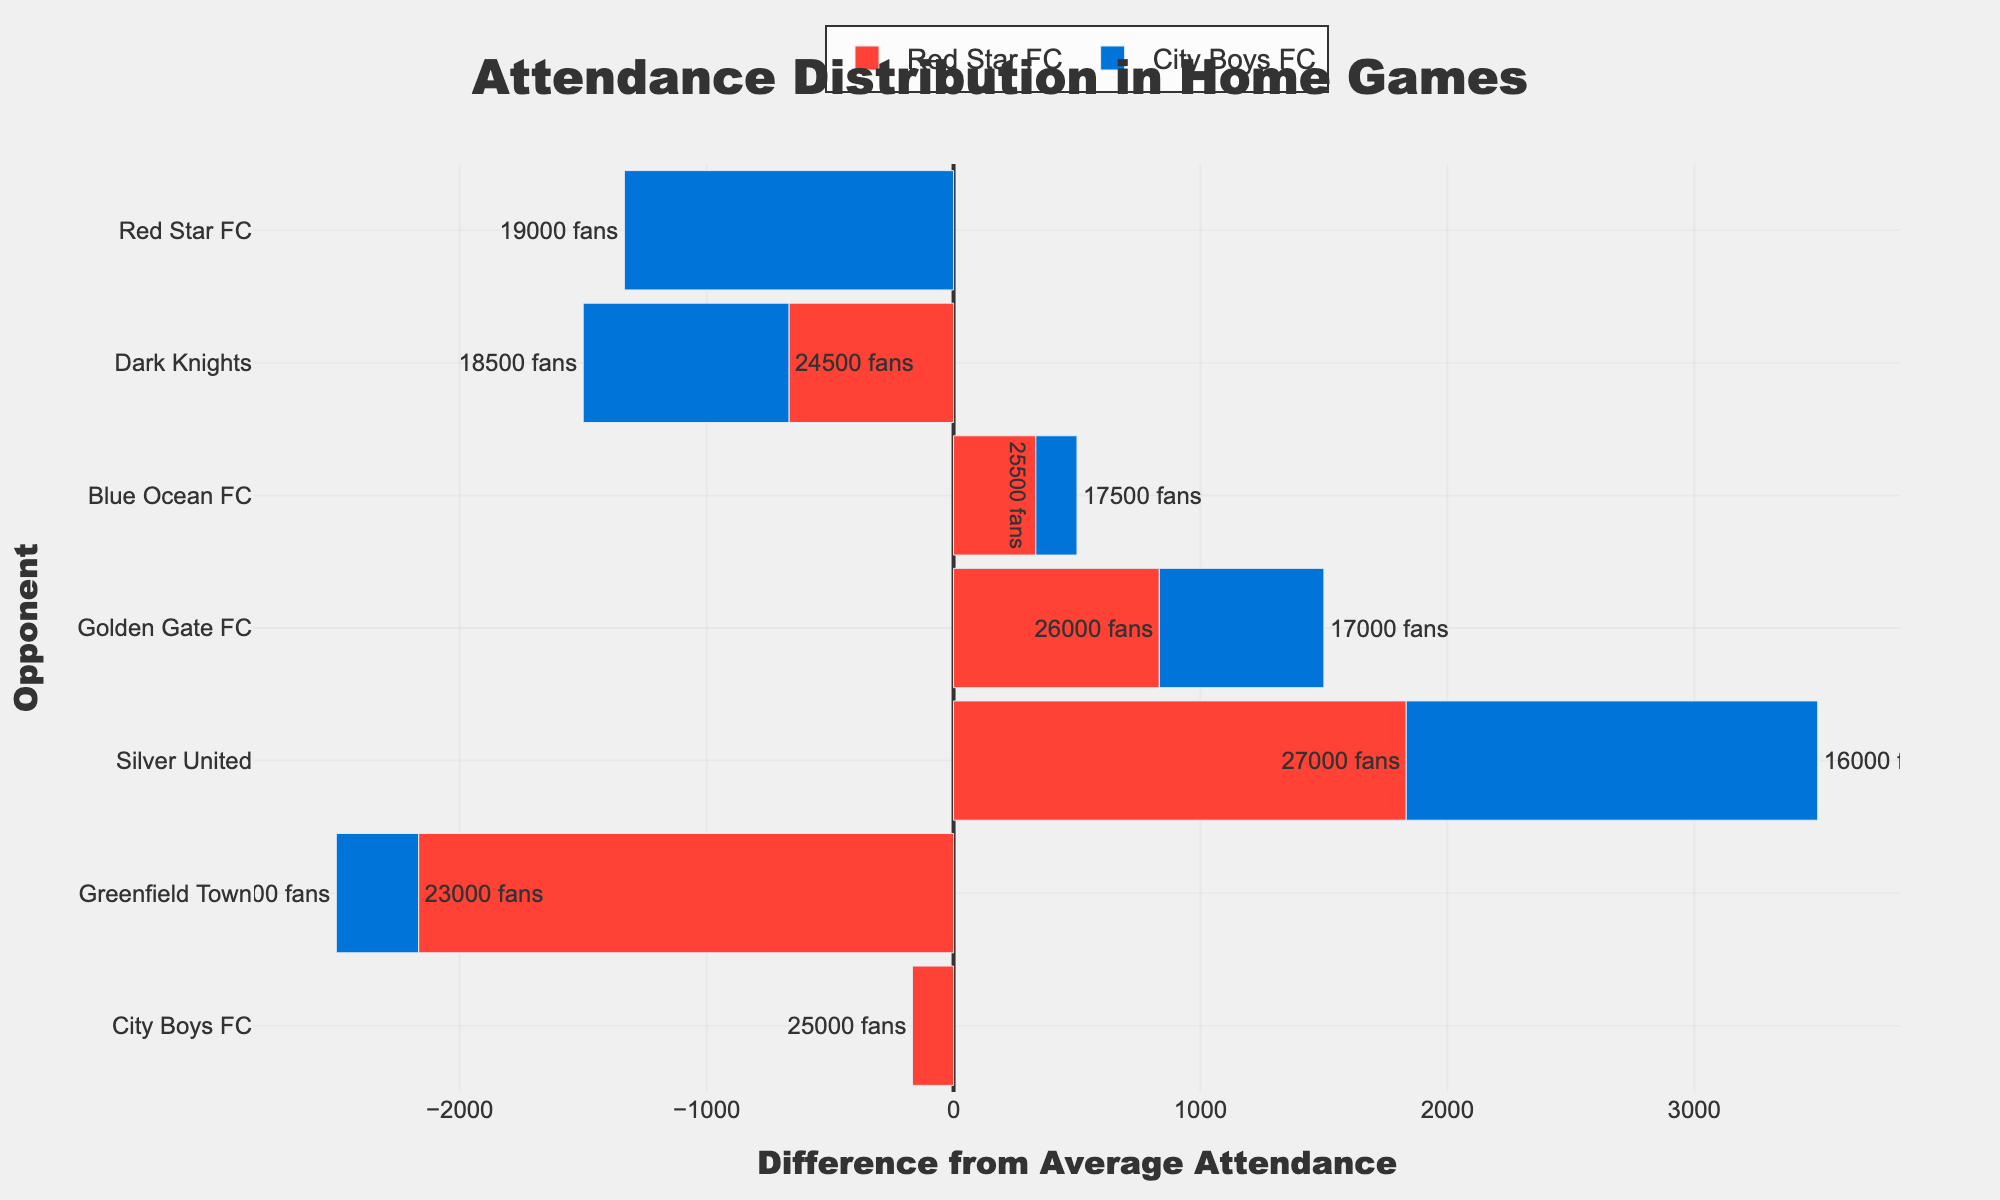Which team has more bars extending to the right side of the zero line? By observing the number of bars that extend to the right side of the zero line, we can see that Red Star FC has more bars on this side compared to City Boys FC.
Answer: Red Star FC Which game had the highest attendance for Red Star FC? By looking for the longest red bar representing Red Star FC which has the largest positive value on the x-axis, the game against Silver United stands out.
Answer: Silver United How did the attendance for City Boys FC against Golden Gate FC compare to their average? By observing the positioning of the bar for City Boys FC against Golden Gate FC, it extends notably to the left of the zero, indicating it is below average.
Answer: Below average What is the difference in attendance between the highest and lowest attended home games for City Boys FC? The highest attendance for City Boys FC was against Red Star FC (19000) and the lowest was against Silver United (16000). Subtracting these gives 19000 - 16000 = 3000.
Answer: 3000 Which team had a game with attendance closest to their average? By checking which bar's length is closest to the zero line, City Boys FC's home game against Greenfield Town appears to be nearest to the average.
Answer: City Boys FC against Greenfield Town What is the attendance difference between Red Star FC's highest and lowest attendance home games? Red Star FC's highest attendance was 27000 against Silver United, and the lowest was 23000 against Greenfield Town. The difference is 27000 - 23000 = 4000.
Answer: 4000 In which game did the attendance for Red Star FC most significantly exceed their average? By finding the longest red bar extending positively, the game against Silver United shows the highest attendance difference positively.
Answer: Silver United Compare the attendance of Red Star FC's game against Golden Gate FC to City Boys FC's game against Red Star FC. Which had higher attendance? By comparing the lengths of the bars representing these games, Red Star FC's game against Golden Gate FC shows to the right and longer than City Boys FC's game against Red Star FC, indicating higher attendance.
Answer: Red Star FC against Golden Gate FC Who had the most negatively deviated attendance from their average and which game was it? Referring to the bar that extends furthest to the left, City Boys FC's game against Silver United shows the most negative deviation from the average.
Answer: City Boys FC against Silver United 